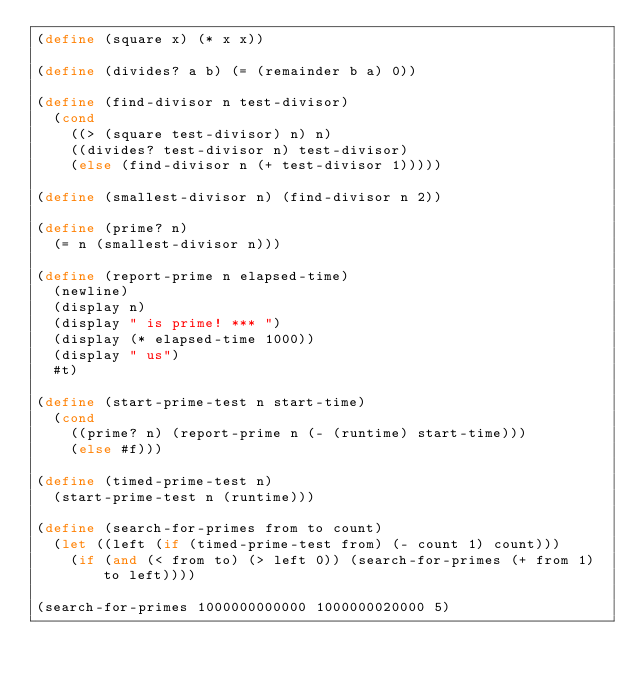<code> <loc_0><loc_0><loc_500><loc_500><_Scheme_>(define (square x) (* x x))

(define (divides? a b) (= (remainder b a) 0))

(define (find-divisor n test-divisor)
  (cond
    ((> (square test-divisor) n) n)
    ((divides? test-divisor n) test-divisor)
    (else (find-divisor n (+ test-divisor 1)))))

(define (smallest-divisor n) (find-divisor n 2))

(define (prime? n)
  (= n (smallest-divisor n)))

(define (report-prime n elapsed-time)
  (newline)
  (display n)
  (display " is prime! *** ")
  (display (* elapsed-time 1000))
  (display " us")
  #t)

(define (start-prime-test n start-time)
  (cond
    ((prime? n) (report-prime n (- (runtime) start-time)))
    (else #f)))

(define (timed-prime-test n)
  (start-prime-test n (runtime)))

(define (search-for-primes from to count)
  (let ((left (if (timed-prime-test from) (- count 1) count)))
    (if (and (< from to) (> left 0)) (search-for-primes (+ from 1) to left))))

(search-for-primes 1000000000000 1000000020000 5)</code> 